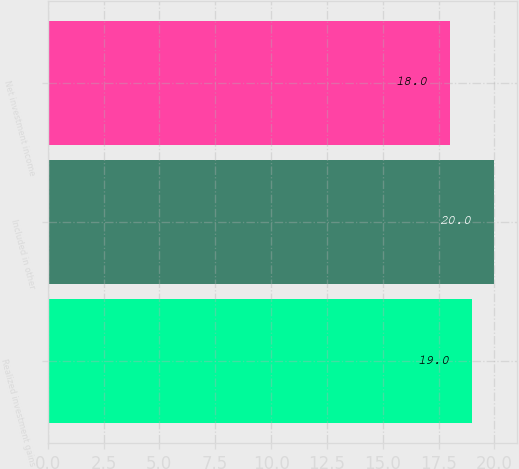<chart> <loc_0><loc_0><loc_500><loc_500><bar_chart><fcel>Realized investment gains<fcel>Included in other<fcel>Net investment income<nl><fcel>19<fcel>20<fcel>18<nl></chart> 